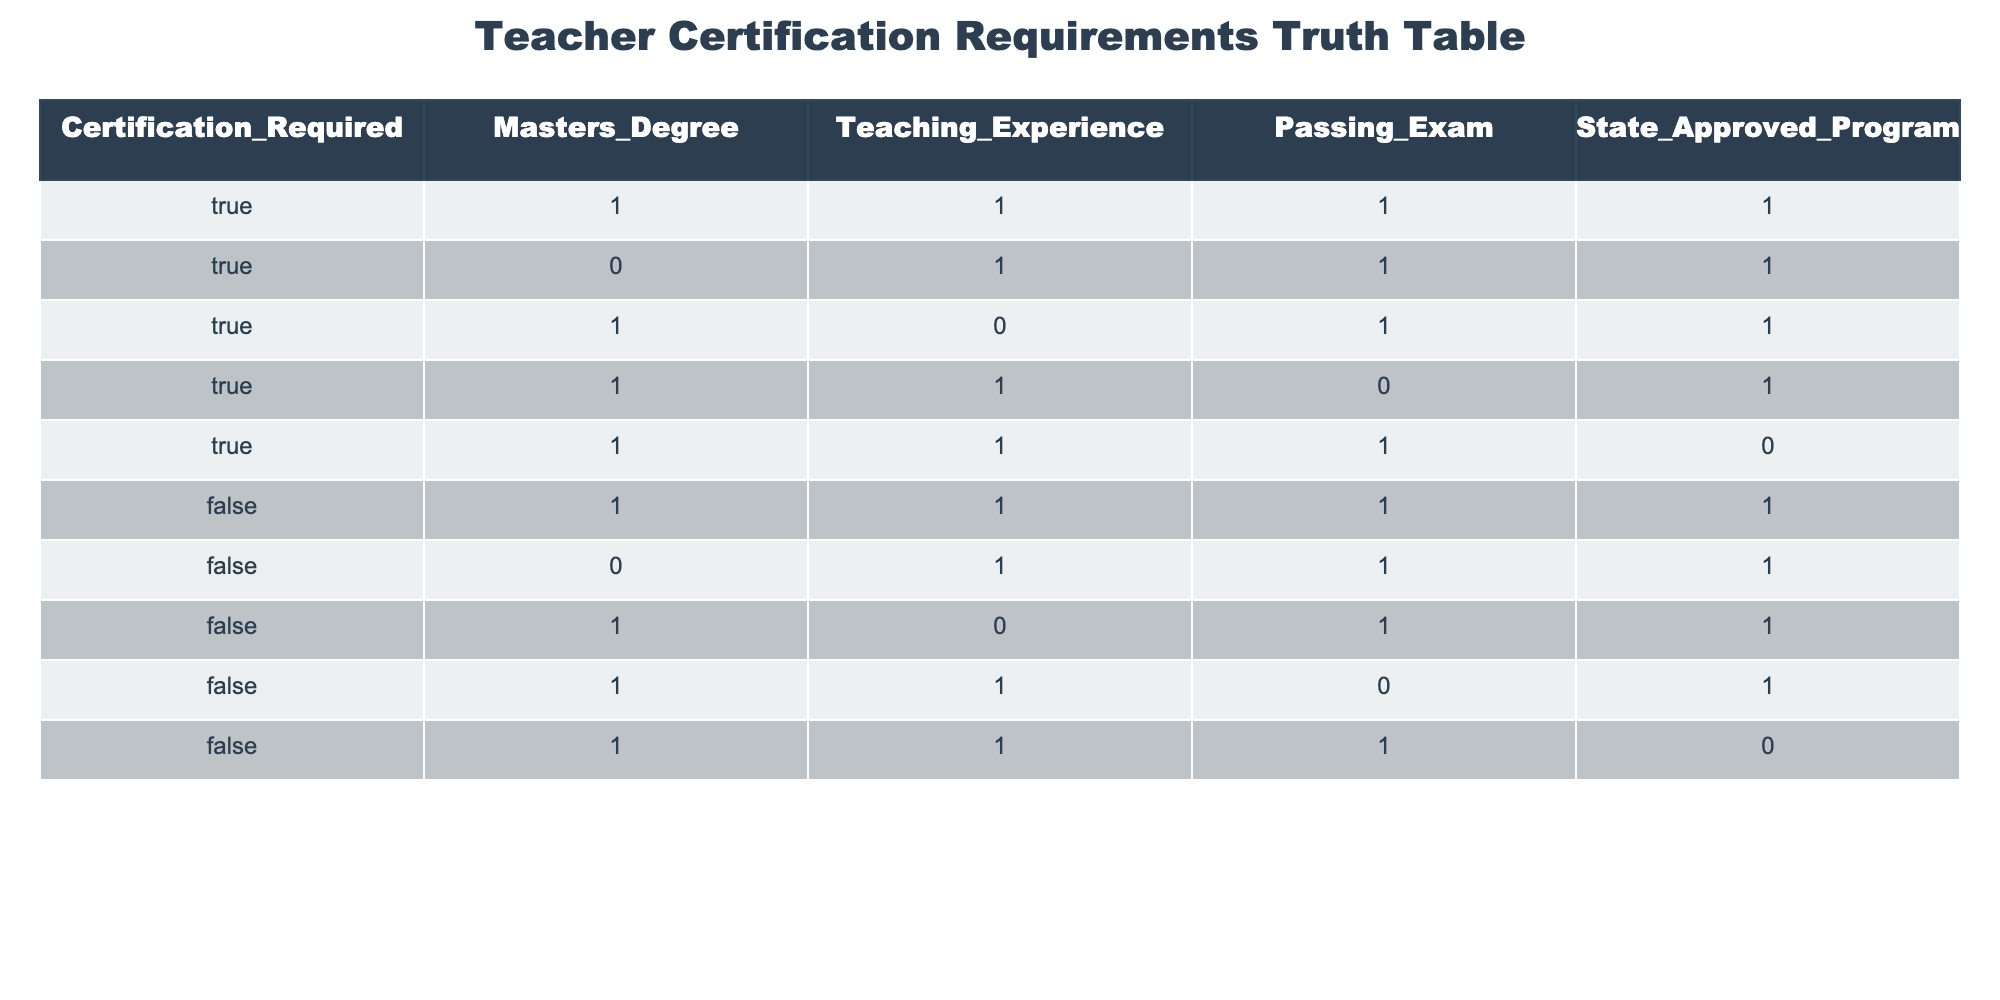What is the total number of configurations where teaching experience is required? To find the total configurations where teaching experience is required, we look for rows that have "TRUE" in the Teaching Experience column. There are six rows (1, 2, 6, 7, 9, 10) that meet this condition.
Answer: 6 Is a master's degree required in any configuration where certification is not required? To answer this, we check the rows where Certification Required is "FALSE". In both rows (6 and 7), the Master's Degree column has "TRUE". Therefore, the answer is yes.
Answer: Yes How many configurations have both a master's degree and a passing exam? Considering the configurations with both Master's Degree and Passing Exam as "TRUE", we see rows 1, 2, 3, and 4. Therefore, there are four configurations that meet this condition.
Answer: 4 Are there any configurations where certification is required without a state-approved program? By inspecting the rows with "TRUE" in Certification Required, we find rows 4 and 5. Row 4 has "FALSE" in State Approved Program, confirming that at least one configuration exists where certification is required without a state-approved program.
Answer: Yes What is the total number of configurations with no teaching experience? We identify rows where the Teaching Experience is "FALSE". Those rows are 5, 7, 8, 9, and 10, totaling five configurations with no teaching experience.
Answer: 5 Is it possible to have a passing exam without a master's degree in any configuration? Reviewing the rows with "TRUE" in Passing Exam, rows 9 and 10 both have "FALSE" in the Master's Degree column. Hence, it is indeed possible to have a passing exam without a master's degree.
Answer: Yes What percentage of configurations require a master's degree? To find the percentage, we count all configurations. There are 10 configurations total. Those that require a master's degree are rows 1, 3, 4, and 5, which total 4. The percentage is (4/10) * 100 = 40%.
Answer: 40% How many configurations have certification required and do not have teaching experience? We check the configurations with "TRUE" for Certification Required (rows 1 to 4) and scan for "FALSE" in Teaching Experience, which occurs in row 3. Thus, there is only one configuration that fits both criteria.
Answer: 1 What is the sum of configurations where both passing exams and state-approved programs are present? We observe the configurations with "TRUE" in both Passing Exam and State Approved Program. Rows 1, 2, 6, and 10 meet this condition, yielding a total of four configurations. The sum is therefore 1 + 1 + 1 + 1 = 4.
Answer: 4 